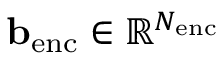Convert formula to latex. <formula><loc_0><loc_0><loc_500><loc_500>b _ { e n c } \in \mathbb { R } ^ { N _ { e n c } }</formula> 